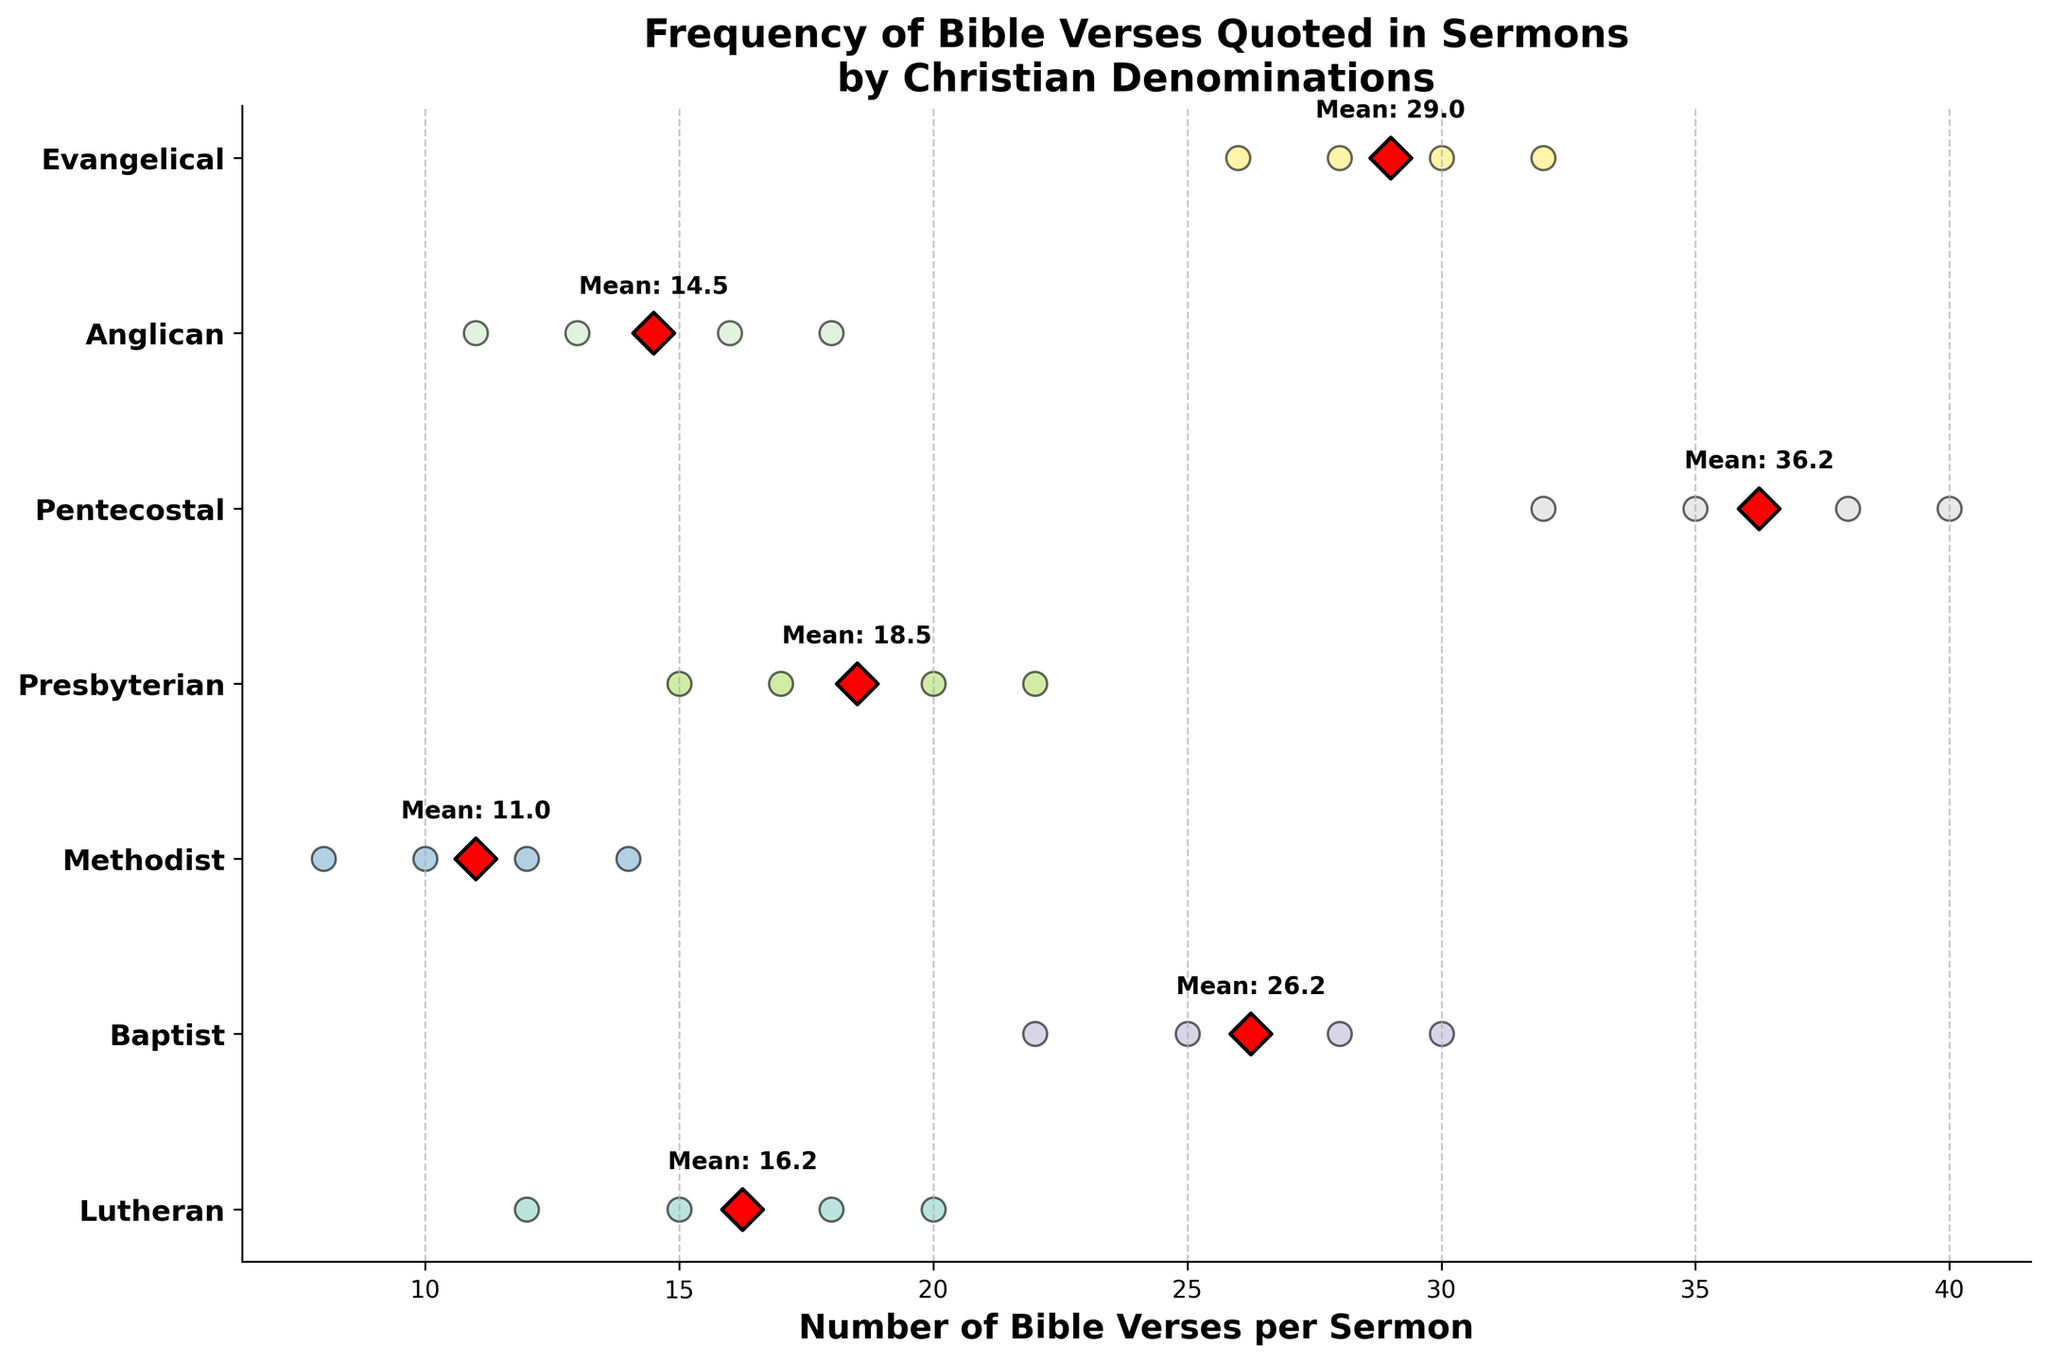What's the title of the plot? The title is written at the top of the figure. It reads: "Frequency of Bible Verses Quoted in Sermons by Christian Denominations".
Answer: Frequency of Bible Verses Quoted in Sermons by Christian Denominations Which denomination has the highest mean number of Bible verses per sermon? Look for the red diamond markers representing the mean and compare their positions. The Pentecostal group has the highest mean value as indicated by its red diamond marker being farthest to the right.
Answer: Pentecostal What's the range of Bible verses quoted per sermon for the Lutheran denomination? Identify the position of all points in the Lutheran section (measured horizontally) and find the minimum and maximum values. The lowest is 12 and the highest is 20. Thus, the range is 20 - 12.
Answer: 8 How many Bible verses do Evangelical sermons quote on average? Locate the red diamond markers and the label indicating the mean for the Evangelical group. The plot shows this value directly next to the marker.
Answer: 29 Which denominations show Bible verses per sermon that coincide in the range of 10 to 20? Identify all denominations and compare their individual point positions falling between 10 and 20 on the x-axis. This range includes Lutheran, Methodist, Presbyterian, and Anglican.
Answer: Lutheran, Methodist, Presbyterian, Anglican How does the variation in Bible verses per sermon of the Methodist group compare to that of the Evangelical group? For each denomination, observe the spread of data points. The Methodist group has a smaller range with tightly clustered data points while the Evangelical group shows a broader spread, indicating higher variation.
Answer: Methodist group has less variation Which denominations have at least one sermon quoting 30 or more Bible verses? Look for points beyond the 30-mark on the x-axis. Only the Baptist, Pentecostal, and Evangelical denominations have points in this range.
Answer: Baptist, Pentecostal, Evangelical What is the mean value of Bible verses quoted in sermons by Presbyterian and Lutheran denominations combined? First, find individual means: Lutheran (15.75) and Presbyterian (18.5). Then, average these two values: (15.75 + 18.5) / 2.
Answer: 17.1 